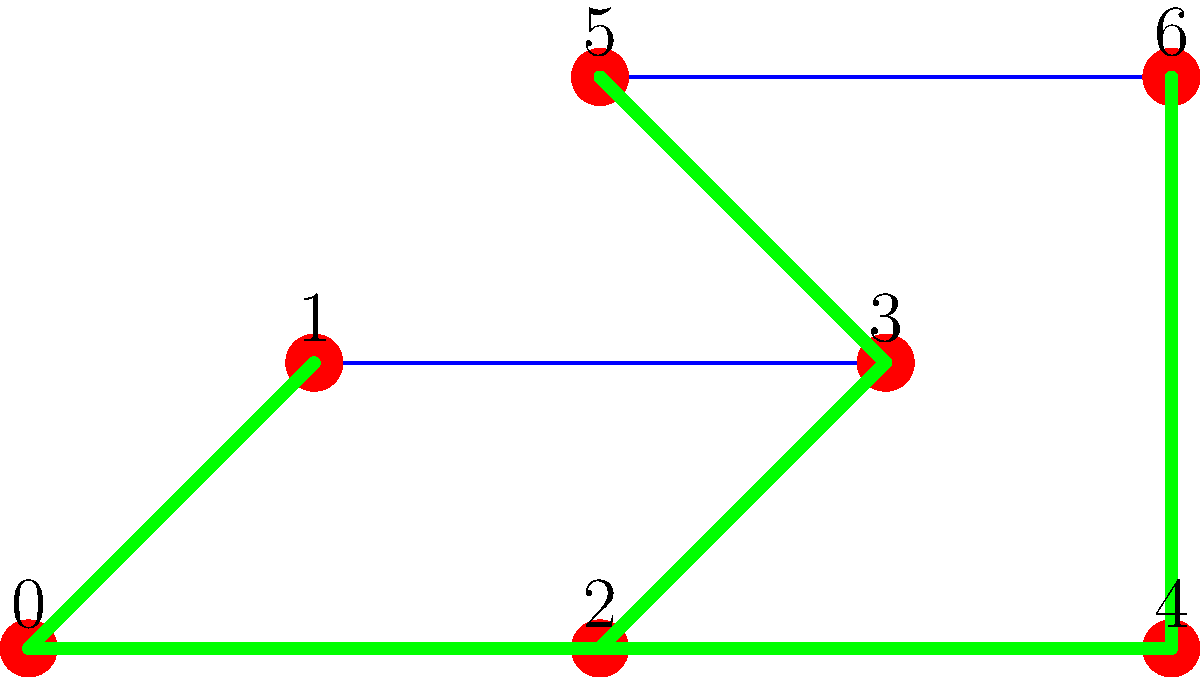In a digital composition incorporating various photo textures, you want to represent the hierarchy of textures using a spanning tree. Given the graph above, where each vertex represents a different texture and edges represent relationships between textures, what is the minimum number of edges that need to be removed to create a spanning tree that maintains the hierarchical structure of the textures? To solve this problem, we need to follow these steps:

1. Count the total number of vertices (n) and edges (m) in the given graph:
   - Number of vertices (n) = 7
   - Number of edges (m) = 8

2. Recall that a spanning tree of a graph with n vertices must have exactly (n-1) edges.

3. Calculate the number of edges that need to be removed:
   - Edges to remove = Total edges - Edges in spanning tree
   - Edges to remove = m - (n-1)
   - Edges to remove = 8 - (7-1)
   - Edges to remove = 8 - 6 = 2

4. Verify that removing 2 edges results in a valid spanning tree:
   - The green edges in the graph show a possible spanning tree
   - This tree connects all 7 vertices with 6 edges
   - It maintains the hierarchical structure of the textures

Therefore, the minimum number of edges that need to be removed to create a spanning tree is 2.
Answer: 2 edges 